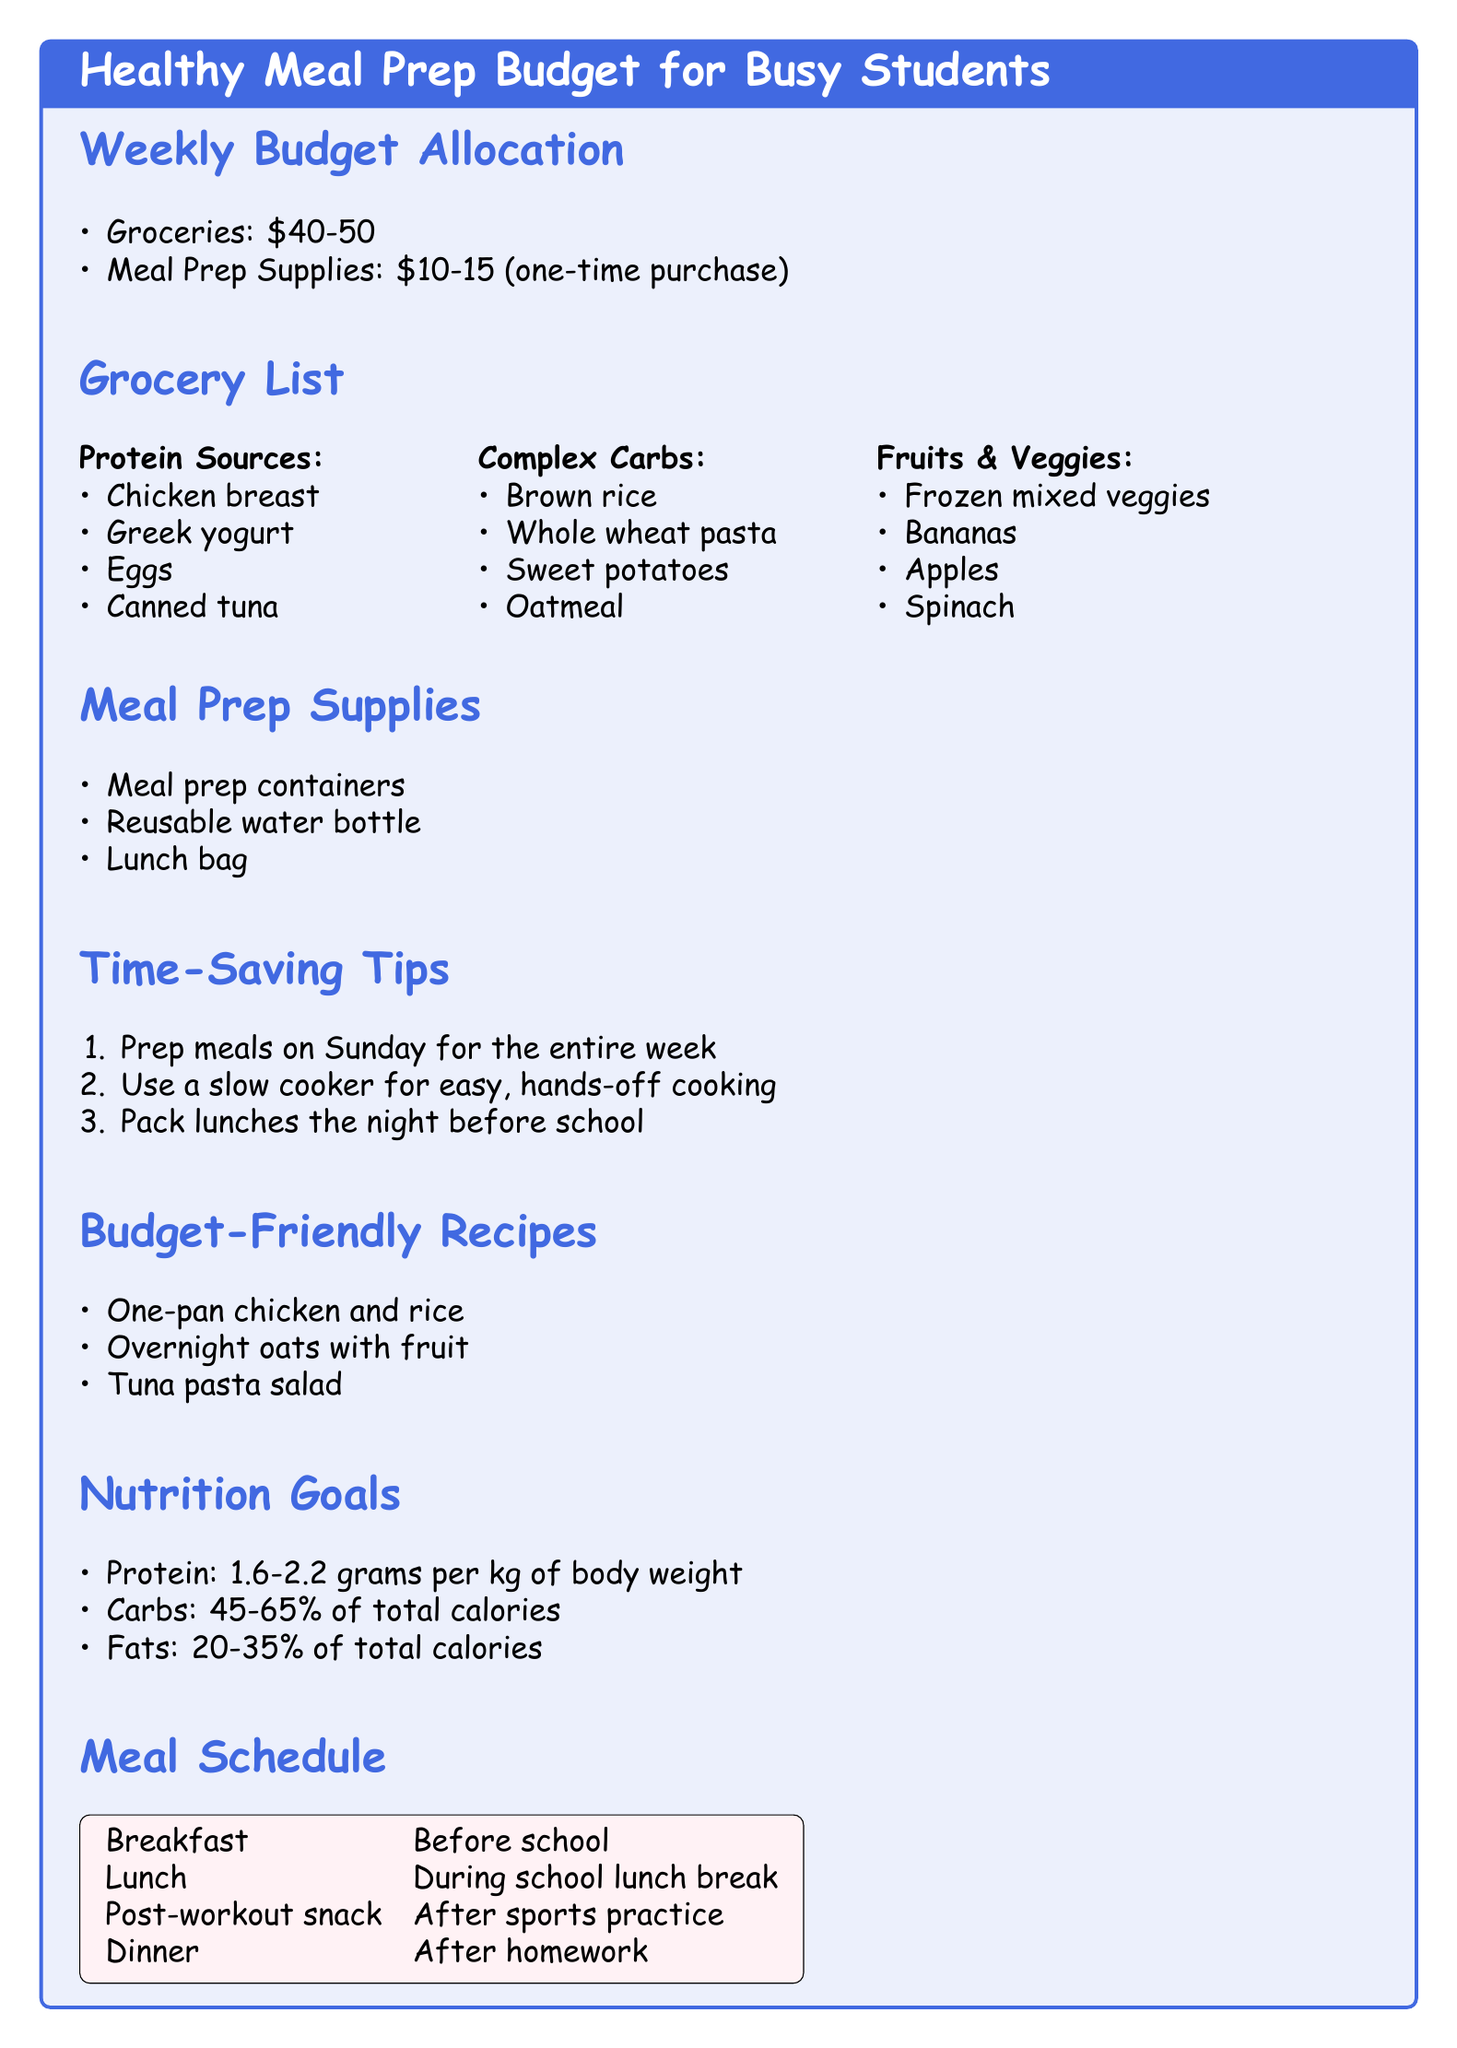What is the weekly budget for groceries? The document states the weekly budget for groceries is between $40 and $50.
Answer: $40-50 What is included in meal prep supplies? The document lists the supplies necessary for meal prep, which include meal prep containers, reusable water bottle, and lunch bag.
Answer: Meal prep containers, reusable water bottle, lunch bag How much should protein make up in grams per kg of body weight? The nutrition goals section states the recommended protein intake is between 1.6 to 2.2 grams per kg of body weight.
Answer: 1.6-2.2 grams What is one time-saving tip mentioned? One of the time-saving tips provided is to prep meals on Sunday for the entire week.
Answer: Prep meals on Sunday What fruit is listed in the grocery list? The grocery list includes several fruits, one of which is bananas.
Answer: Bananas What is the cost range for meal prep supplies? The document mentions that the cost for meal prep supplies is a one-time purchase ranging from $10 to $15.
Answer: $10-15 What meal is scheduled before school? The meal schedule states that breakfast is scheduled before school.
Answer: Breakfast What percentage of total calories should fats make up? The nutrition goals section specifies that fats should make up 20-35% of total calories.
Answer: 20-35% 